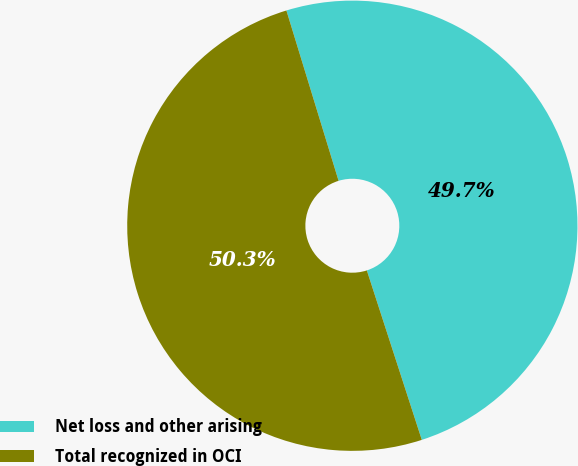<chart> <loc_0><loc_0><loc_500><loc_500><pie_chart><fcel>Net loss and other arising<fcel>Total recognized in OCI<nl><fcel>49.74%<fcel>50.26%<nl></chart> 